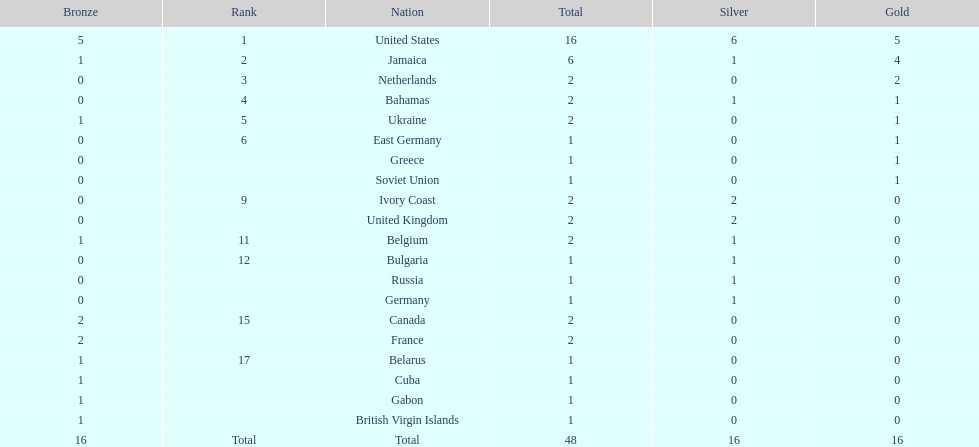What country won the most silver medals? United States. 